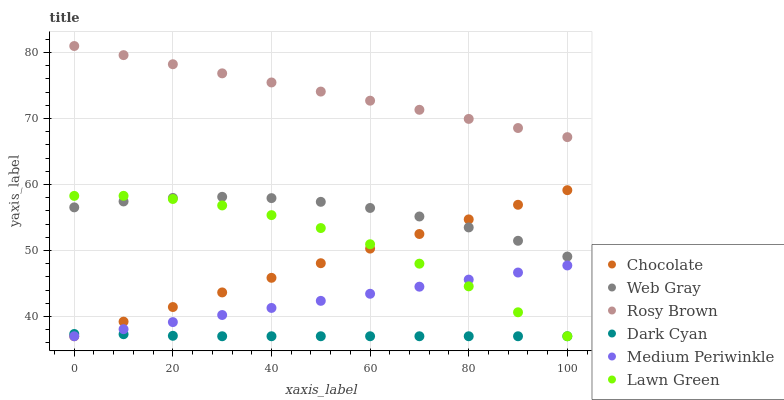Does Dark Cyan have the minimum area under the curve?
Answer yes or no. Yes. Does Rosy Brown have the maximum area under the curve?
Answer yes or no. Yes. Does Web Gray have the minimum area under the curve?
Answer yes or no. No. Does Web Gray have the maximum area under the curve?
Answer yes or no. No. Is Chocolate the smoothest?
Answer yes or no. Yes. Is Lawn Green the roughest?
Answer yes or no. Yes. Is Web Gray the smoothest?
Answer yes or no. No. Is Web Gray the roughest?
Answer yes or no. No. Does Lawn Green have the lowest value?
Answer yes or no. Yes. Does Web Gray have the lowest value?
Answer yes or no. No. Does Rosy Brown have the highest value?
Answer yes or no. Yes. Does Web Gray have the highest value?
Answer yes or no. No. Is Dark Cyan less than Rosy Brown?
Answer yes or no. Yes. Is Rosy Brown greater than Lawn Green?
Answer yes or no. Yes. Does Web Gray intersect Lawn Green?
Answer yes or no. Yes. Is Web Gray less than Lawn Green?
Answer yes or no. No. Is Web Gray greater than Lawn Green?
Answer yes or no. No. Does Dark Cyan intersect Rosy Brown?
Answer yes or no. No. 